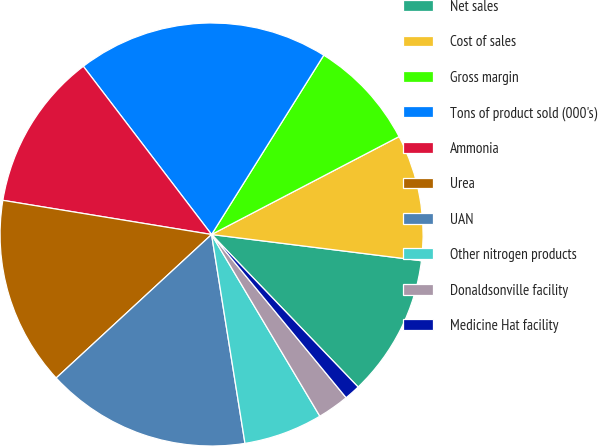<chart> <loc_0><loc_0><loc_500><loc_500><pie_chart><fcel>Net sales<fcel>Cost of sales<fcel>Gross margin<fcel>Tons of product sold (000's)<fcel>Ammonia<fcel>Urea<fcel>UAN<fcel>Other nitrogen products<fcel>Donaldsonville facility<fcel>Medicine Hat facility<nl><fcel>10.84%<fcel>9.64%<fcel>8.44%<fcel>19.27%<fcel>12.05%<fcel>14.45%<fcel>15.66%<fcel>6.03%<fcel>2.42%<fcel>1.21%<nl></chart> 